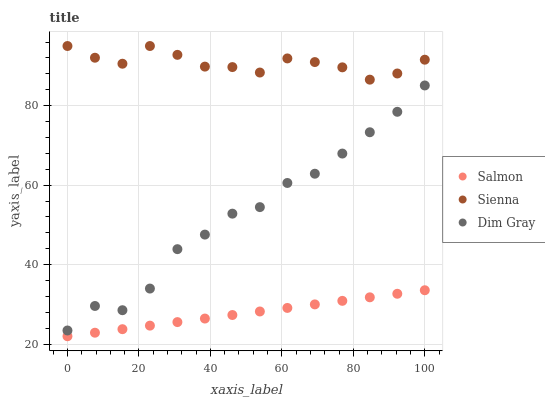Does Salmon have the minimum area under the curve?
Answer yes or no. Yes. Does Sienna have the maximum area under the curve?
Answer yes or no. Yes. Does Dim Gray have the minimum area under the curve?
Answer yes or no. No. Does Dim Gray have the maximum area under the curve?
Answer yes or no. No. Is Salmon the smoothest?
Answer yes or no. Yes. Is Dim Gray the roughest?
Answer yes or no. Yes. Is Dim Gray the smoothest?
Answer yes or no. No. Is Salmon the roughest?
Answer yes or no. No. Does Salmon have the lowest value?
Answer yes or no. Yes. Does Dim Gray have the lowest value?
Answer yes or no. No. Does Sienna have the highest value?
Answer yes or no. Yes. Does Dim Gray have the highest value?
Answer yes or no. No. Is Salmon less than Dim Gray?
Answer yes or no. Yes. Is Dim Gray greater than Salmon?
Answer yes or no. Yes. Does Salmon intersect Dim Gray?
Answer yes or no. No. 